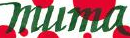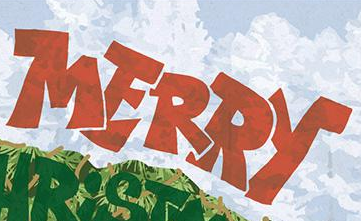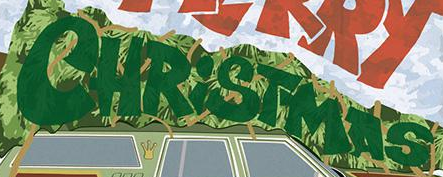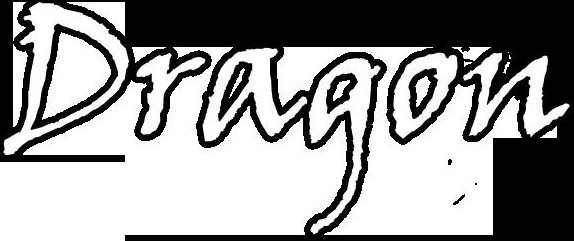What text is displayed in these images sequentially, separated by a semicolon? muma; MERRY; CHRiSTMAS; Dragon 